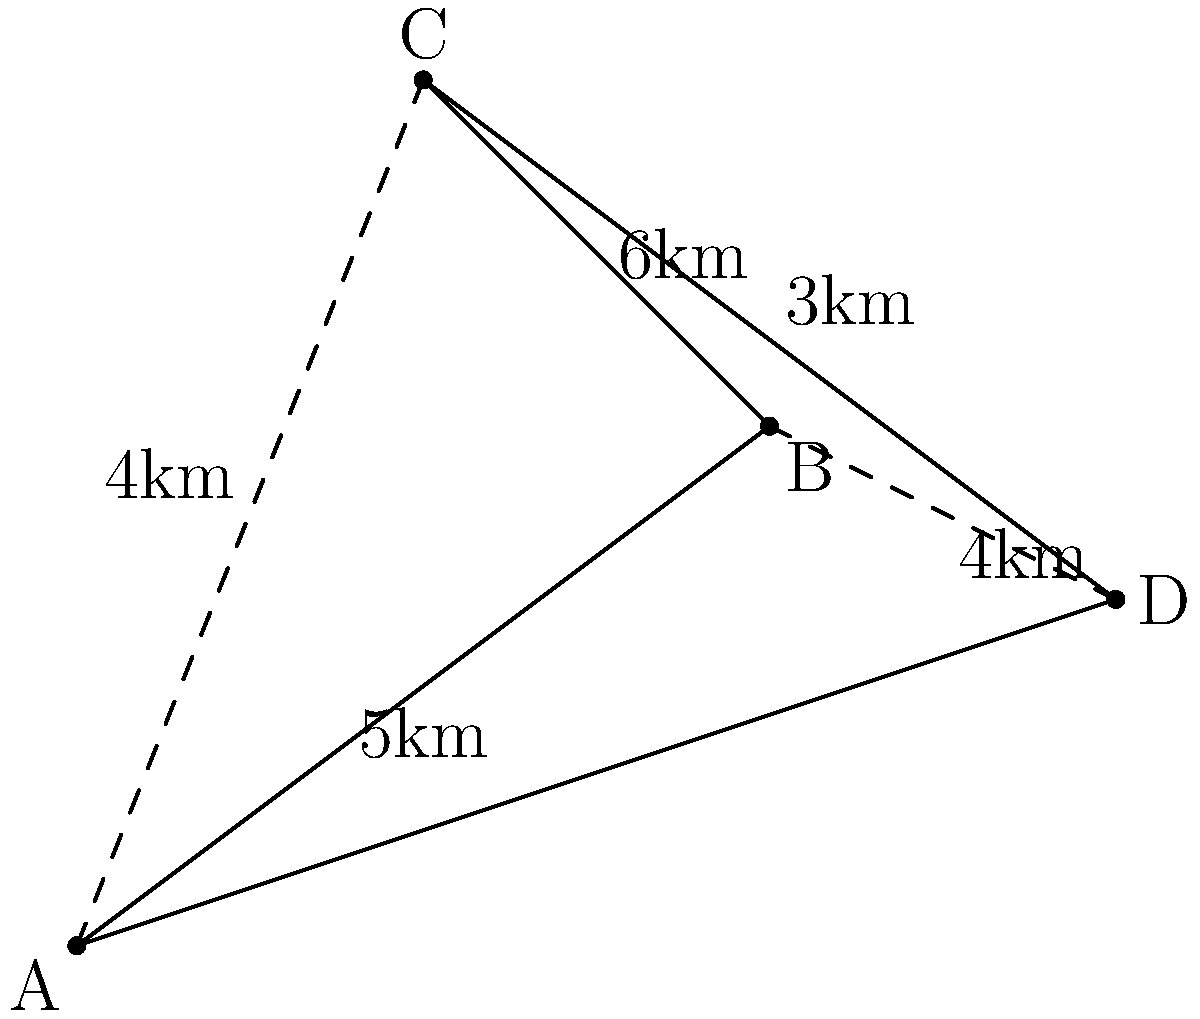As a tourism coordinator, you're planning a route to visit four popular destinations (A, B, C, and D) in a new city. The distances between these locations are shown on the map. What is the shortest possible route that visits all four destinations exactly once and returns to the starting point? To find the shortest route, we need to consider all possible paths that visit each destination once and return to the starting point. This is known as the Traveling Salesman Problem.

1. List all possible routes:
   ABCDA, ABDCA, ACBDA, ACDBA, ADBCA, ADCBA

2. Calculate the distance for each route:
   ABCDA: 5 + 6 + 3 + 4 = 18 km
   ABDCA: 5 + 4 + 3 + 4 = 16 km
   ACBDA: 4 + 6 + 4 + 4 = 18 km
   ACDBA: 4 + 3 + 4 + 5 = 16 km
   ADBCA: 4 + 4 + 6 + 4 = 18 km
   ADCBA: 4 + 3 + 6 + 5 = 18 km

3. Identify the shortest route(s):
   Both ABDCA and ACDBA have the shortest distance of 16 km.

4. Choose one of the shortest routes:
   Let's select ABDCA as our answer.

The shortest route is ABDCA, with a total distance of 16 km.
Answer: ABDCA (16 km) 